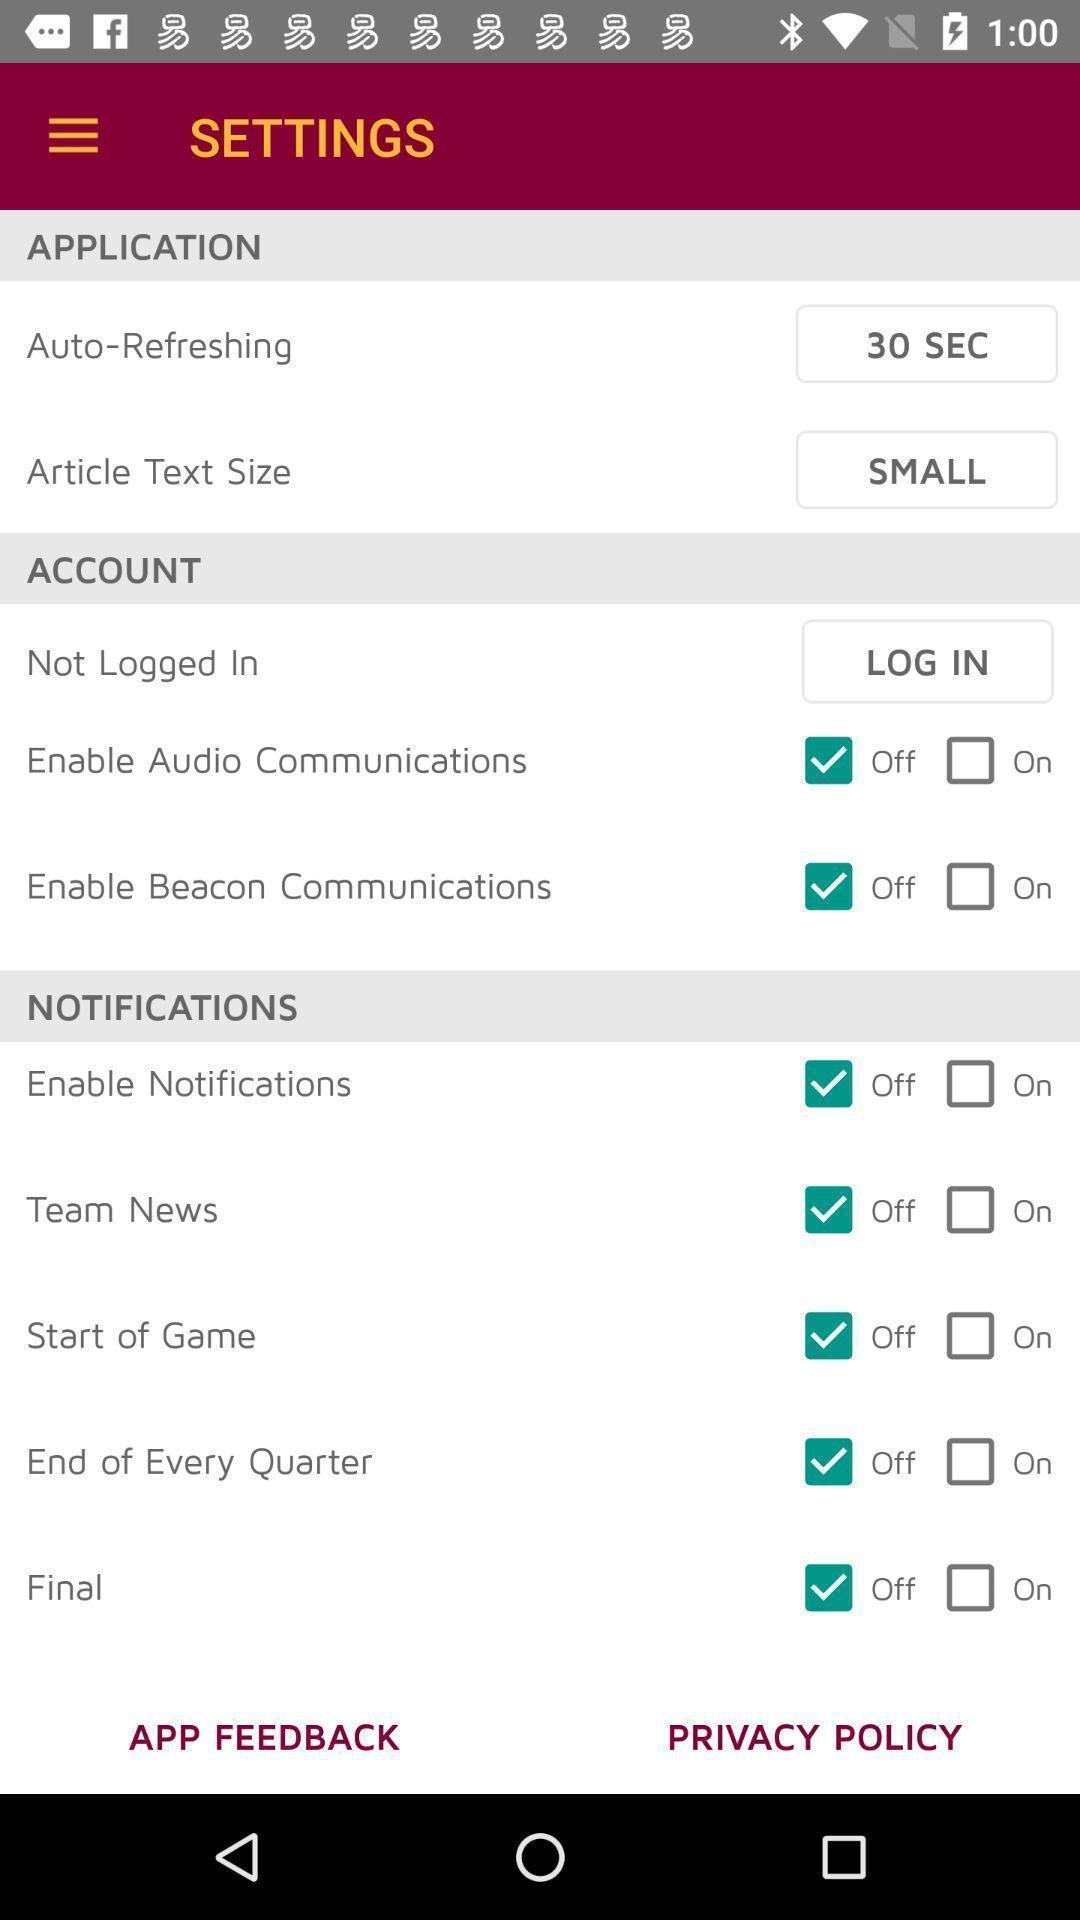Provide a description of this screenshot. Screen displaying list of settings. 